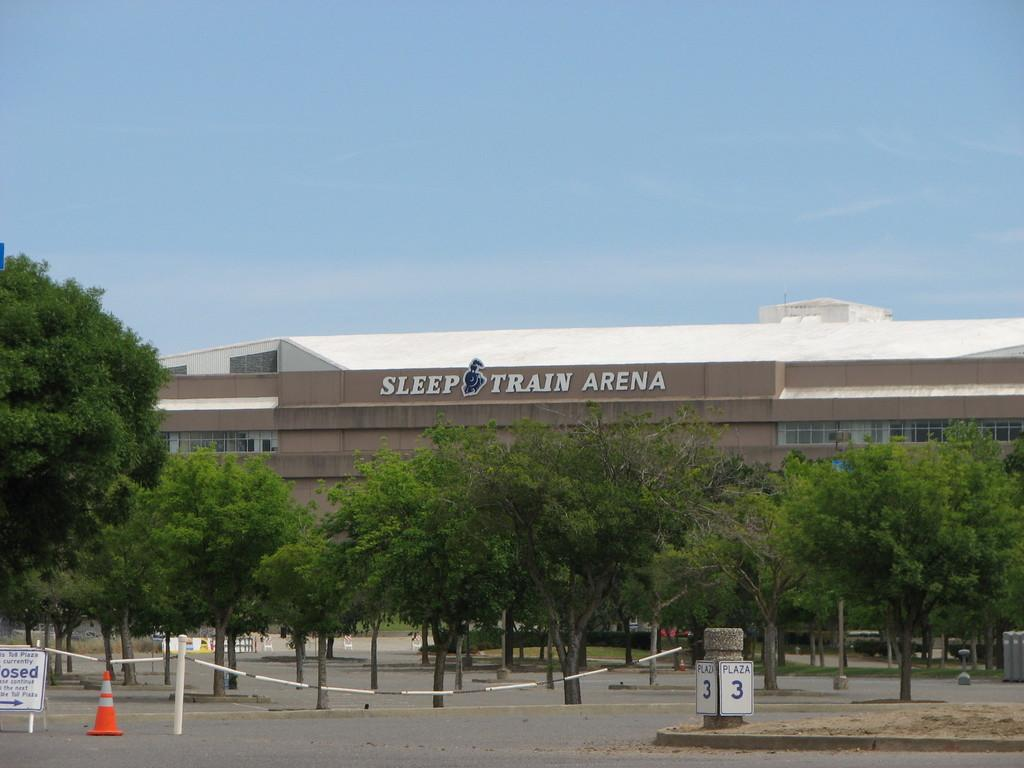What objects are located in the foreground of the image? There are bollards, a safety pole, and a direction board in the foreground of the image. What can be seen in the background of the image? There are trees, a building, and the sky visible in the background of the image. Can you tell me how many elbows are visible in the image? There are no elbows present in the image. Who is the owner of the building in the background of the image? The image does not provide information about the owner of the building. 